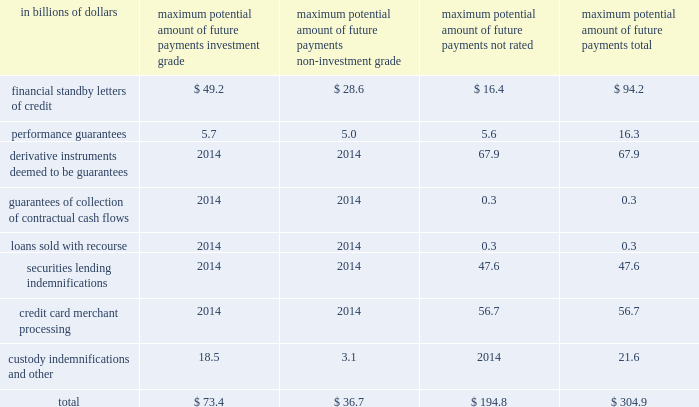Billion at december 31 , 2008 and december 31 , 2007 , respectively .
Securities and other marketable assets held as collateral amounted to $ 27 billion and $ 54 billion , the majority of which collateral is held to reimburse losses realized under securities lending indemnifications .
The decrease from the prior year is in line with the decrease in the notional amount of these indemnifications , which are collateralized .
Additionally , letters of credit in favor of the company held as collateral amounted to $ 503 million and $ 370 million at december 31 , 2008 and december 31 , 2007 , respectively .
Other property may also be available to the company to cover losses under certain guarantees and indemnifications ; however , the value of such property has not been determined .
Performance risk citigroup evaluates the performance risk of its guarantees based on the assigned referenced counterparty internal or external ratings .
Where external ratings are used , investment-grade ratings are considered to be baa/bbb and above , while anything below is considered non-investment grade .
The citigroup internal ratings are in line with the related external rating system .
On certain underlying referenced credits or entities , ratings are not available .
Such referenced credits are included in the 201cnot-rated 201d category .
The maximum potential amount of the future payments related to guarantees and credit derivatives sold is determined to be the notional amount of these contracts , which is the par amount of the assets guaranteed .
Presented in the table below is the maximum potential amount of future payments classified based upon internal and external credit ratings as of december 31 , 2008 .
As previously mentioned , the determination of the maximum potential future payments is based on the notional amount of the guarantees without consideration of possible recoveries under recourse provisions or from collateral held or pledged .
Such amounts bear no relationship to the anticipated losses , if any , on these guarantees. .
Credit derivatives a credit derivative is a bilateral contract between a buyer and a seller under which the seller sells protection against the credit risk of a particular entity ( 201creference entity 201d or 201creference credit 201d ) .
Credit derivatives generally require that the seller of credit protection make payments to the buyer upon the occurrence of predefined credit events ( commonly referred to as 201csettlement triggers 201d ) .
These settlement triggers are defined by the form of the derivative and the reference credit and are generally limited to the market standard of failure to pay on indebtedness and bankruptcy of the reference credit and , in a more limited range of transactions , debt restructuring .
Credit derivative transactions referring to emerging market reference credits will also typically include additional settlement triggers to cover the acceleration of indebtedness and the risk of repudiation or a payment moratorium .
In certain transactions , protection may be provided on a portfolio of referenced credits or asset-backed securities .
The seller of such protection may not be required to make payment until a specified amount of losses has occurred with respect to the portfolio and/or may only be required to pay for losses up to a specified amount .
The company makes markets in and trades a range of credit derivatives , both on behalf of clients as well as for its own account .
Through these contracts , the company either purchases or writes protection on either a single name or a portfolio of reference credits .
The company uses credit derivatives to help mitigate credit risk in its corporate loan portfolio and other cash positions , to take proprietary trading positions , and to facilitate client transactions .
The range of credit derivatives sold includes credit default swaps , total return swaps and credit options .
A credit default swap is a contract in which , for a fee , a protection seller ( guarantor ) agrees to reimburse a protection buyer ( beneficiary ) for any losses that occur due to a credit event on a reference entity .
If there is no credit default event or settlement trigger , as defined by the specific derivative contract , then the guarantor makes no payments to the beneficiary and receives only the contractually specified fee .
However , if a credit event occurs and in accordance with the specific derivative contract sold , the guarantor will be required to make a payment to the beneficiary .
A total return swap transfers the total economic performance of a reference asset , which includes all associated cash flows , as well as capital appreciation or depreciation .
The protection buyer ( beneficiary ) receives a floating rate of interest and any depreciation on the reference asset from the protection seller ( guarantor ) , and in return the protection seller receives the cash flows associated with the reference asset , plus any appreciation .
Thus , the beneficiary will be obligated to make a payment any time the floating interest rate payment according to the total return swap agreement and any depreciation of the reference asset exceed the cash flows associated with the underlying asset .
A total return swap may terminate upon a default of the reference asset subject to the provisions in the related total return swap agreement between the protection seller ( guarantor ) and the protection buyer ( beneficiary ) . .
What percent of total maximum potential amount of future payments are backed by performance guarrantees ? \\n? 
Computations: (16.3 / 304.9)
Answer: 0.05346. 